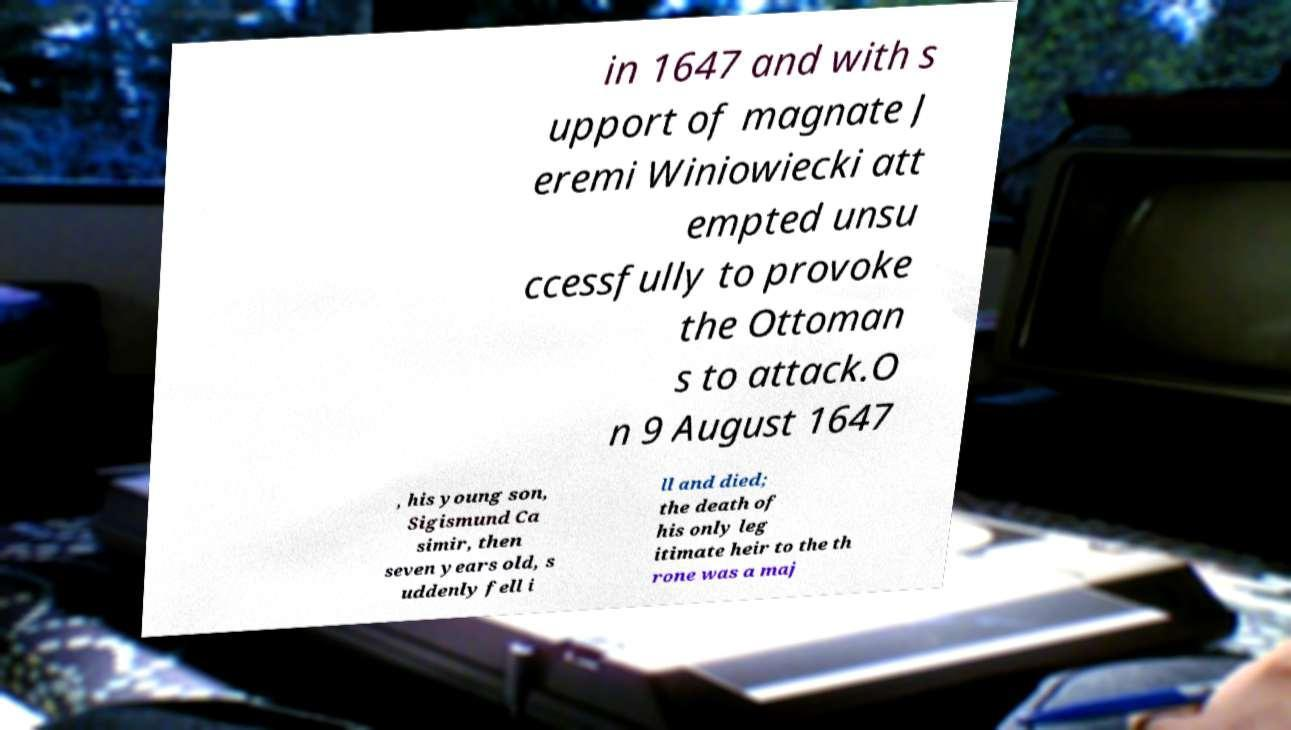For documentation purposes, I need the text within this image transcribed. Could you provide that? in 1647 and with s upport of magnate J eremi Winiowiecki att empted unsu ccessfully to provoke the Ottoman s to attack.O n 9 August 1647 , his young son, Sigismund Ca simir, then seven years old, s uddenly fell i ll and died; the death of his only leg itimate heir to the th rone was a maj 